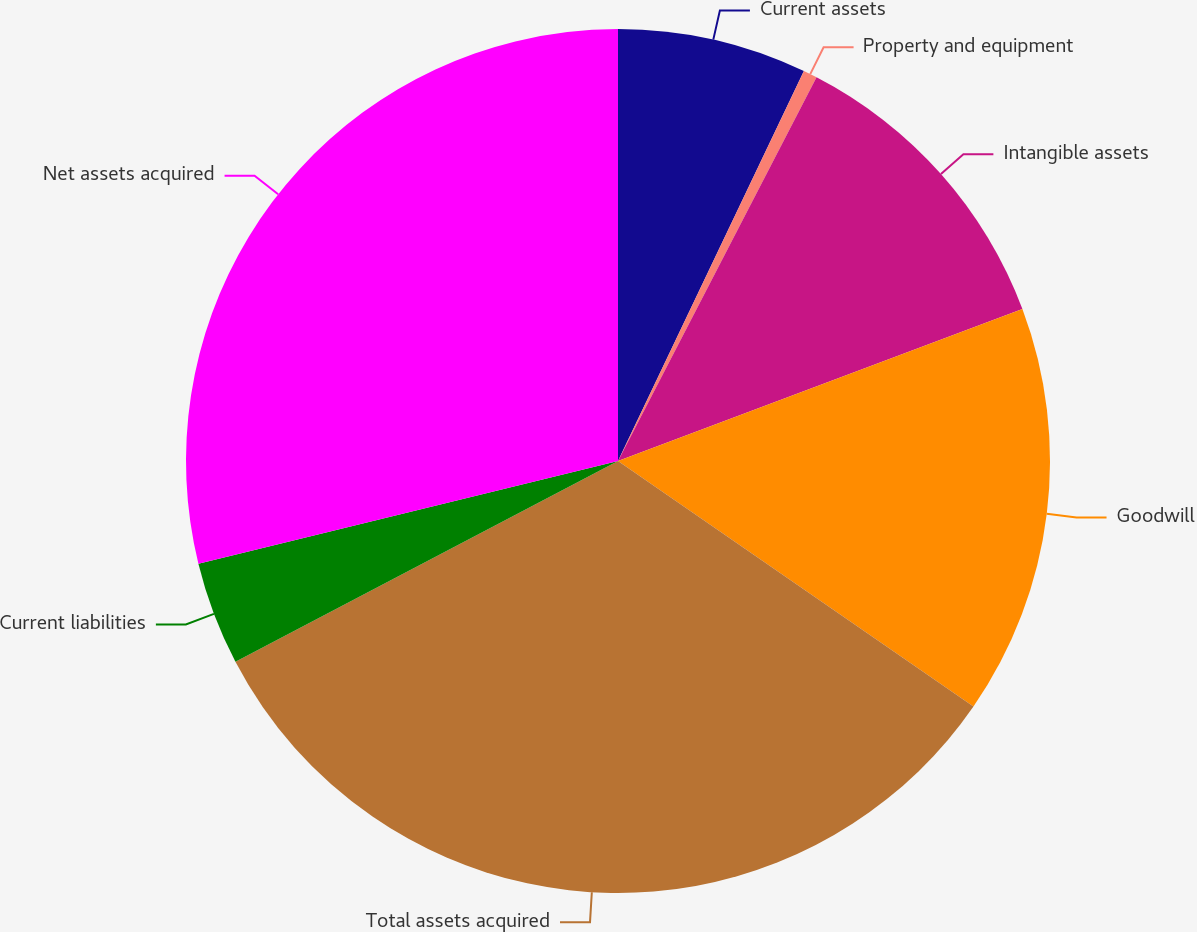<chart> <loc_0><loc_0><loc_500><loc_500><pie_chart><fcel>Current assets<fcel>Property and equipment<fcel>Intangible assets<fcel>Goodwill<fcel>Total assets acquired<fcel>Current liabilities<fcel>Net assets acquired<nl><fcel>7.08%<fcel>0.52%<fcel>11.68%<fcel>15.34%<fcel>32.69%<fcel>3.87%<fcel>28.82%<nl></chart> 